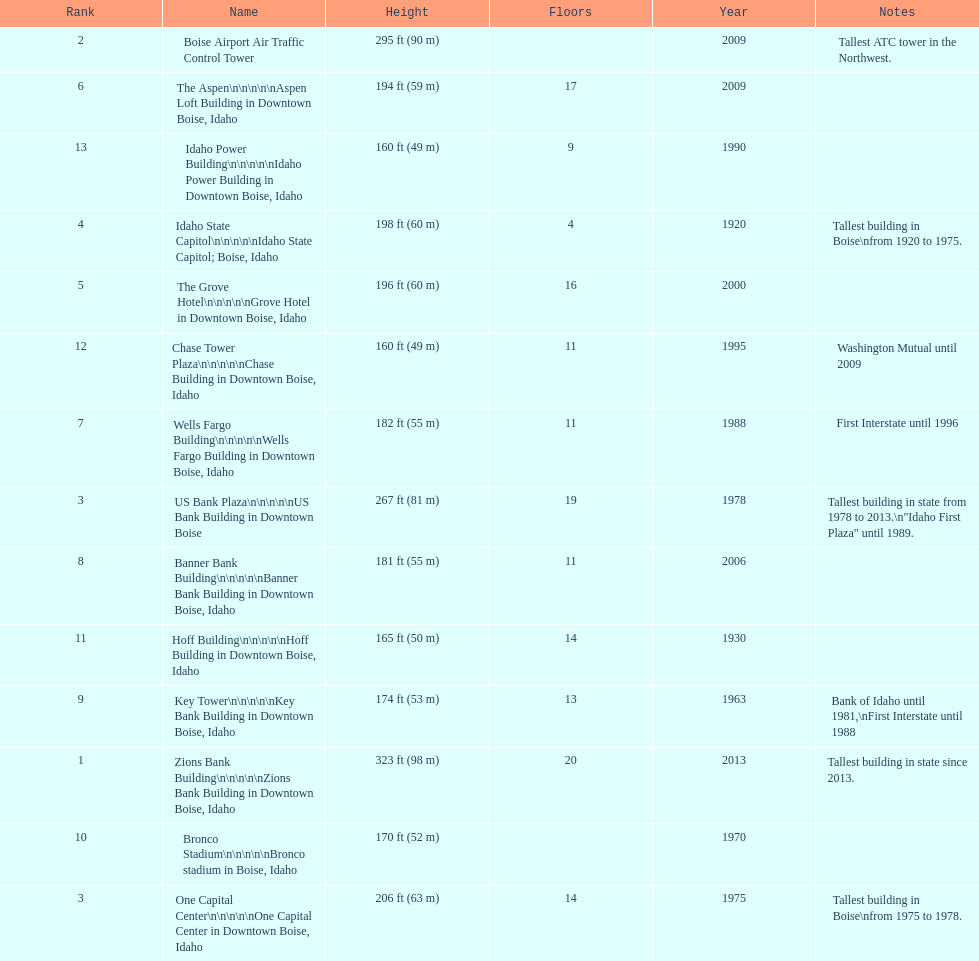How many of these buildings were built after 1975 8. 